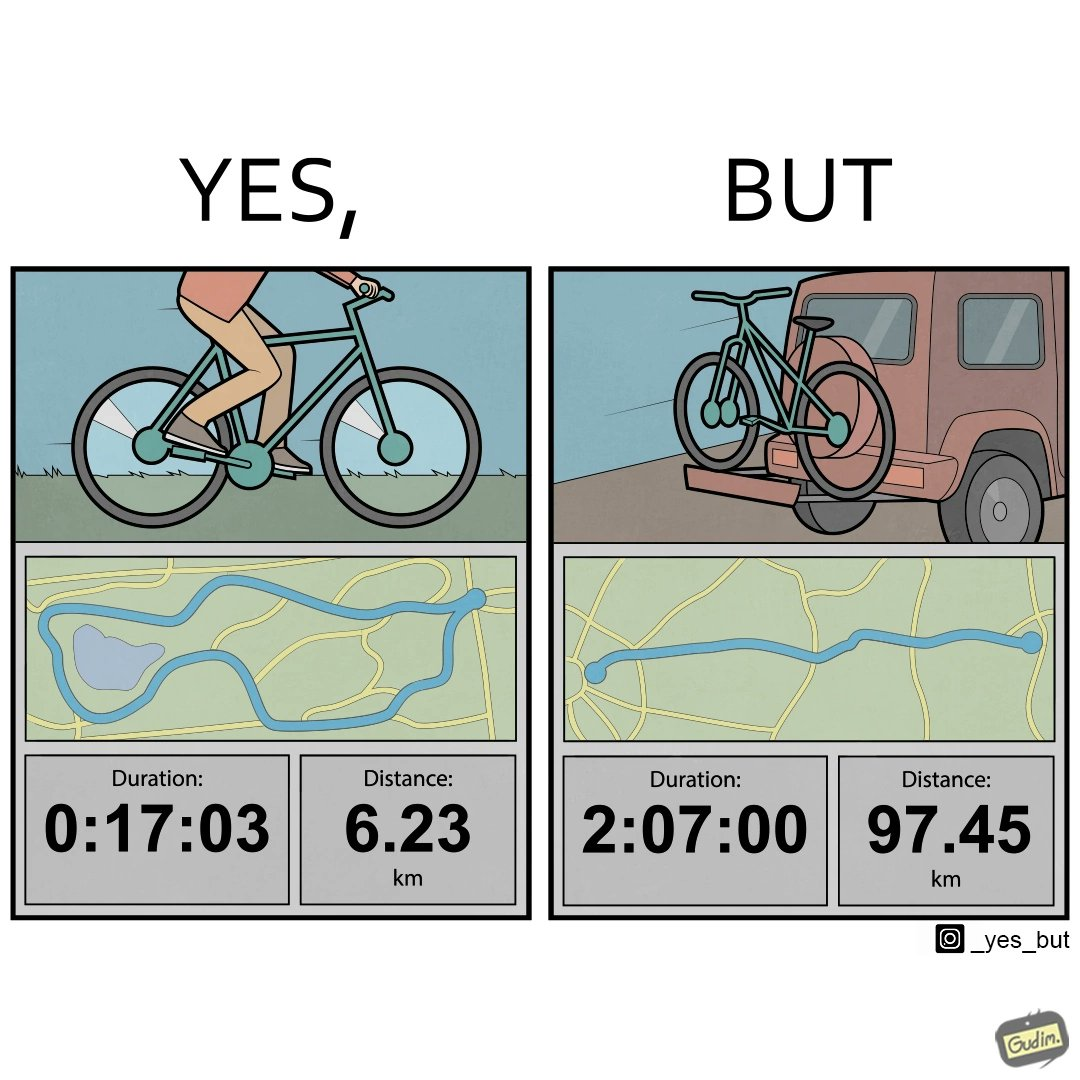Would you classify this image as satirical? Yes, this image is satirical. 